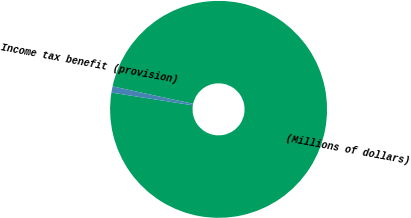Convert chart to OTSL. <chart><loc_0><loc_0><loc_500><loc_500><pie_chart><fcel>(Millions of dollars)<fcel>Income tax benefit (provision)<nl><fcel>99.07%<fcel>0.93%<nl></chart> 